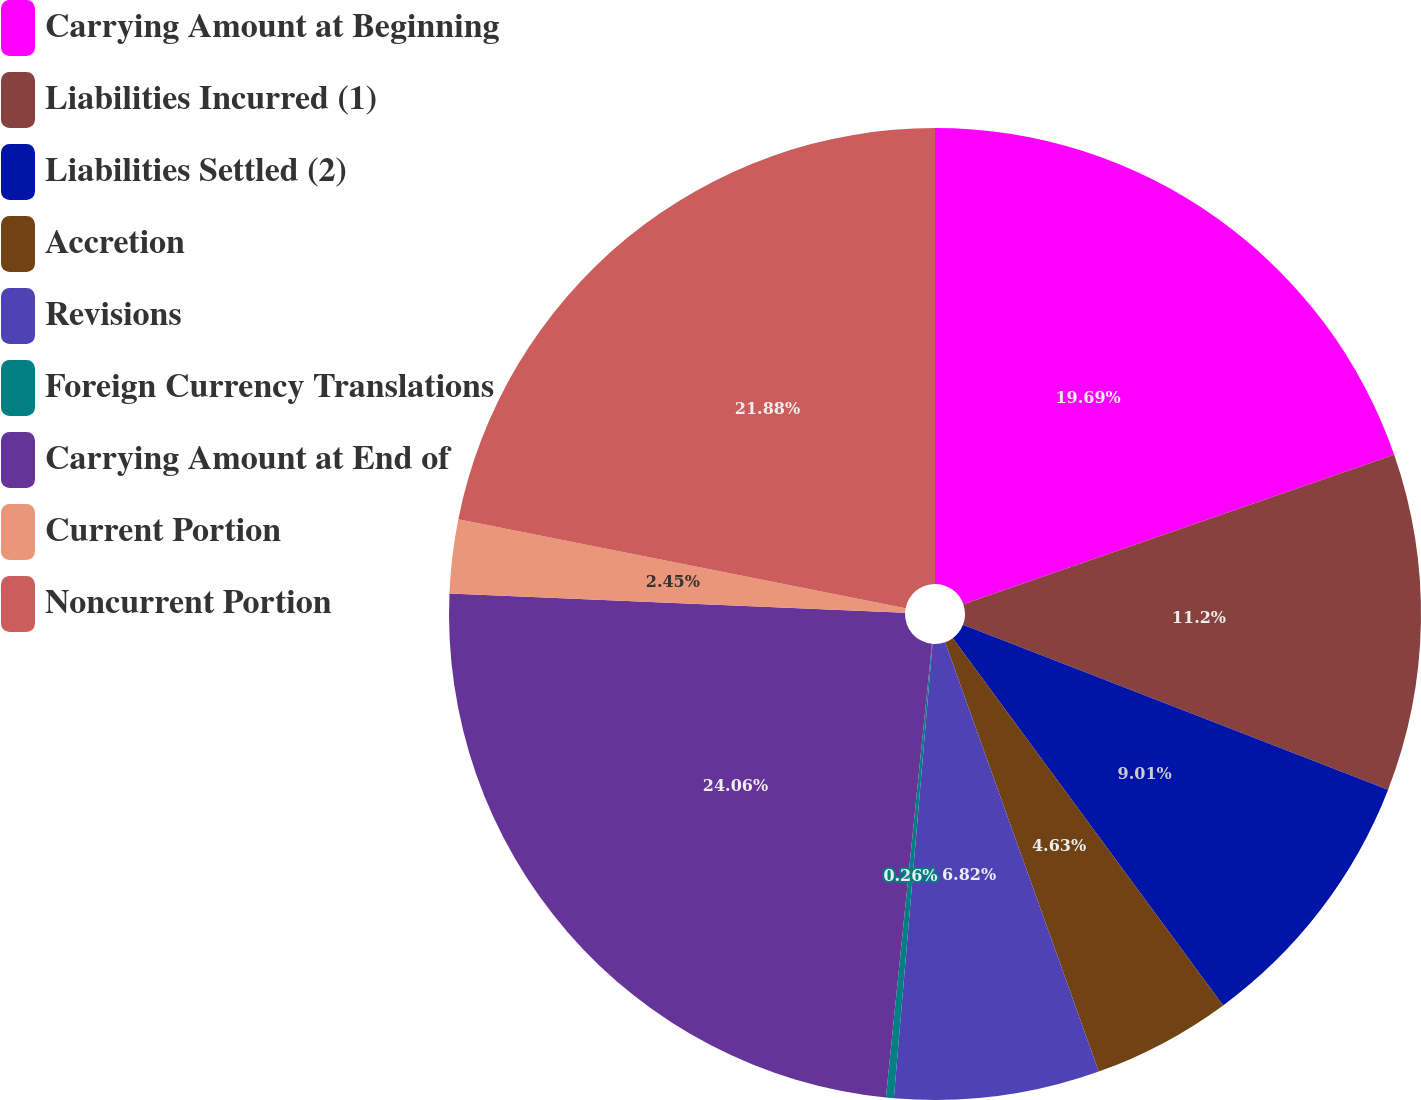<chart> <loc_0><loc_0><loc_500><loc_500><pie_chart><fcel>Carrying Amount at Beginning<fcel>Liabilities Incurred (1)<fcel>Liabilities Settled (2)<fcel>Accretion<fcel>Revisions<fcel>Foreign Currency Translations<fcel>Carrying Amount at End of<fcel>Current Portion<fcel>Noncurrent Portion<nl><fcel>19.69%<fcel>11.2%<fcel>9.01%<fcel>4.63%<fcel>6.82%<fcel>0.26%<fcel>24.06%<fcel>2.45%<fcel>21.88%<nl></chart> 